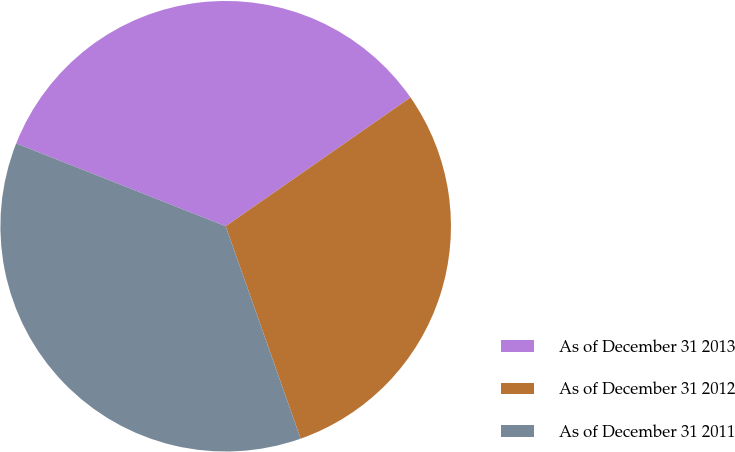<chart> <loc_0><loc_0><loc_500><loc_500><pie_chart><fcel>As of December 31 2013<fcel>As of December 31 2012<fcel>As of December 31 2011<nl><fcel>34.32%<fcel>29.29%<fcel>36.39%<nl></chart> 